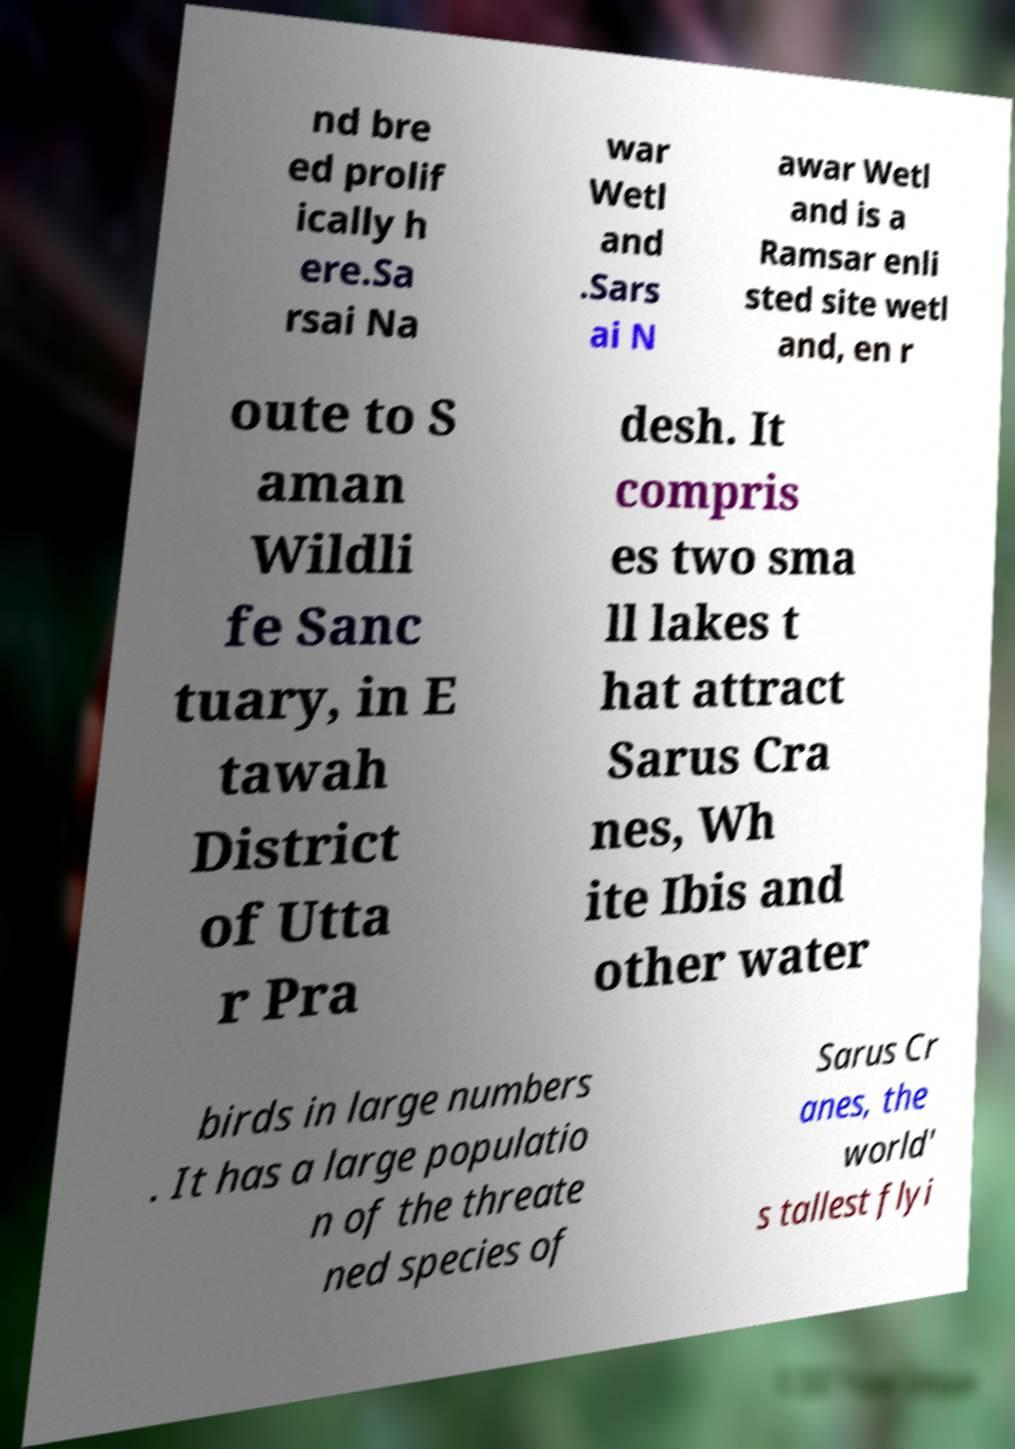Please identify and transcribe the text found in this image. nd bre ed prolif ically h ere.Sa rsai Na war Wetl and .Sars ai N awar Wetl and is a Ramsar enli sted site wetl and, en r oute to S aman Wildli fe Sanc tuary, in E tawah District of Utta r Pra desh. It compris es two sma ll lakes t hat attract Sarus Cra nes, Wh ite Ibis and other water birds in large numbers . It has a large populatio n of the threate ned species of Sarus Cr anes, the world' s tallest flyi 